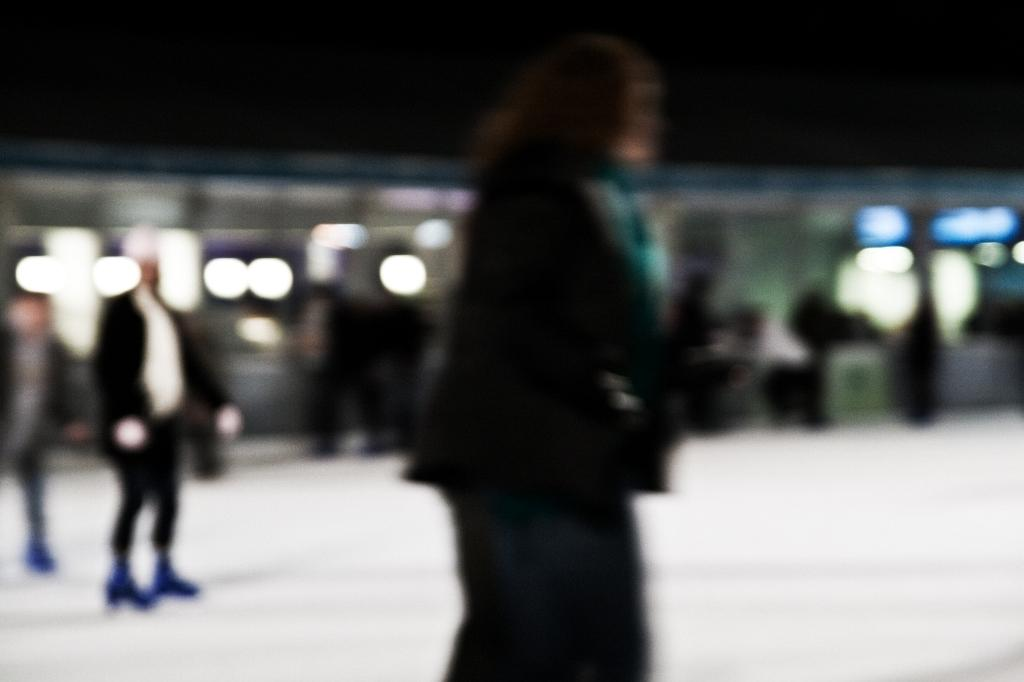What is happening in the image? There are people standing in the image. What can be seen in the background of the image? There are lights visible in the background of the image. How would you describe the quality of the image? The image is blurred. What type of seed is being used as a scarf by the person in the image? There is no seed or scarf present in the image; it only shows people standing and lights in the background. 